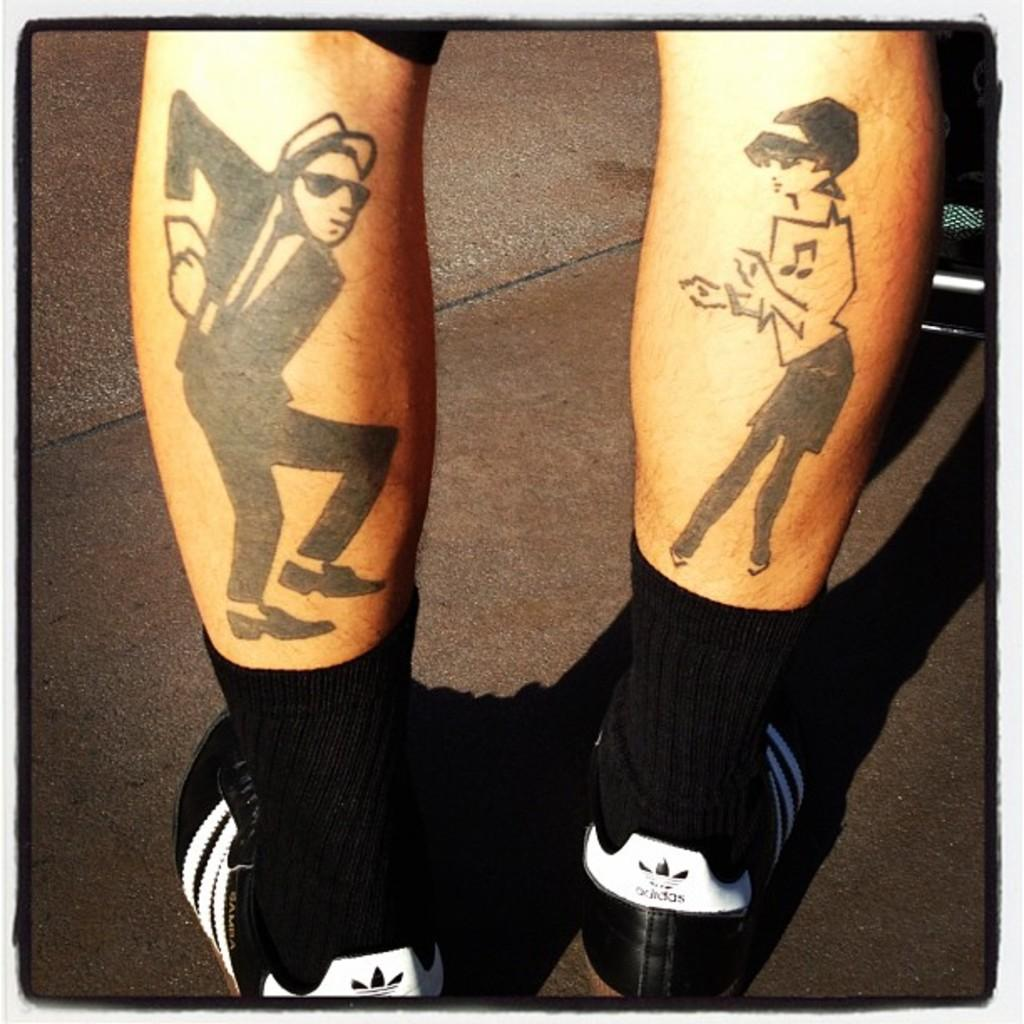What is depicted on the legs in the image? There is a painting on the legs in the image. How many legs are visible in the image? There are two legs visible in the image. What type of crow is sitting on the father's bed in the image? There is no crow or bed present in the image; it only features two legs with a painting on them. 